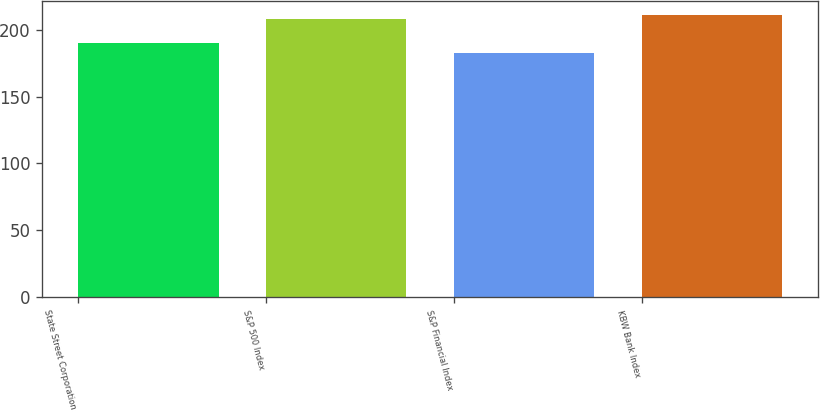Convert chart to OTSL. <chart><loc_0><loc_0><loc_500><loc_500><bar_chart><fcel>State Street Corporation<fcel>S&P 500 Index<fcel>S&P Financial Index<fcel>KBW Bank Index<nl><fcel>190<fcel>208<fcel>183<fcel>211<nl></chart> 